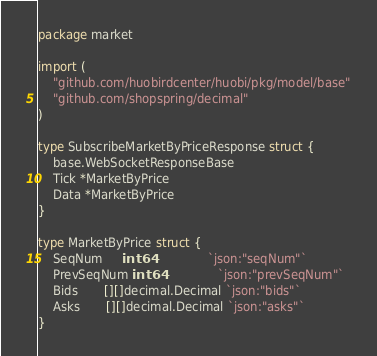Convert code to text. <code><loc_0><loc_0><loc_500><loc_500><_Go_>package market

import (
	"github.com/huobirdcenter/huobi/pkg/model/base"
	"github.com/shopspring/decimal"
)

type SubscribeMarketByPriceResponse struct {
	base.WebSocketResponseBase
	Tick *MarketByPrice
	Data *MarketByPrice
}

type MarketByPrice struct {
	SeqNum     int64               `json:"seqNum"`
	PrevSeqNum int64               `json:"prevSeqNum"`
	Bids       [][]decimal.Decimal `json:"bids"`
	Asks       [][]decimal.Decimal `json:"asks"`
}
</code> 